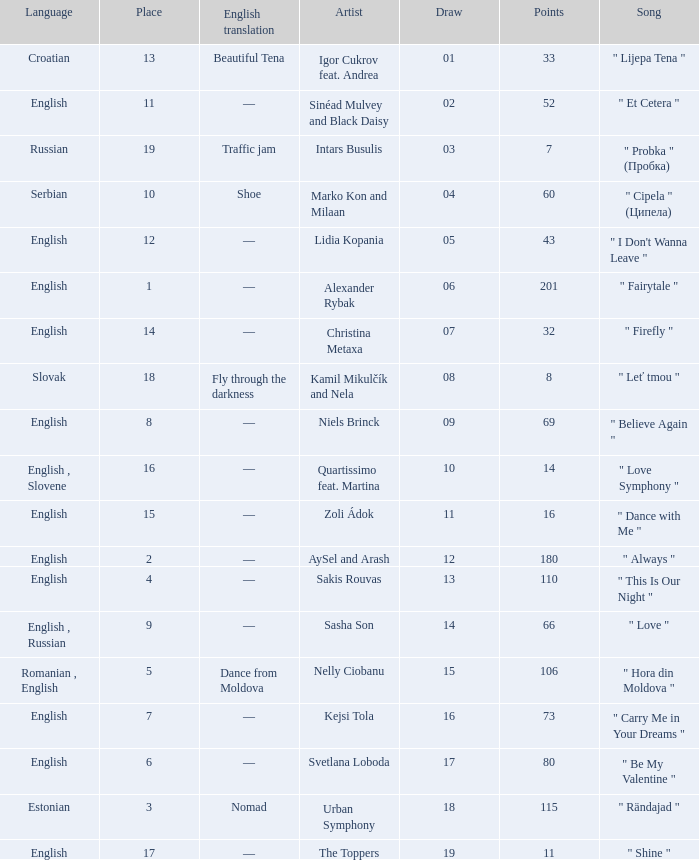What is the place when the draw is less than 12 and the artist is quartissimo feat. martina? 16.0. 